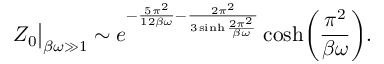<formula> <loc_0><loc_0><loc_500><loc_500>Z _ { 0 } \Big | _ { \beta \omega \gg 1 } \sim e ^ { - \frac { 5 \pi ^ { 2 } } { 1 2 \beta \omega } - \frac { 2 \pi ^ { 2 } } { 3 \sinh \frac { 2 \pi ^ { 2 } } { \beta \omega } } } \cosh \Big ( \frac { \pi ^ { 2 } } { \beta \omega } \Big ) .</formula> 